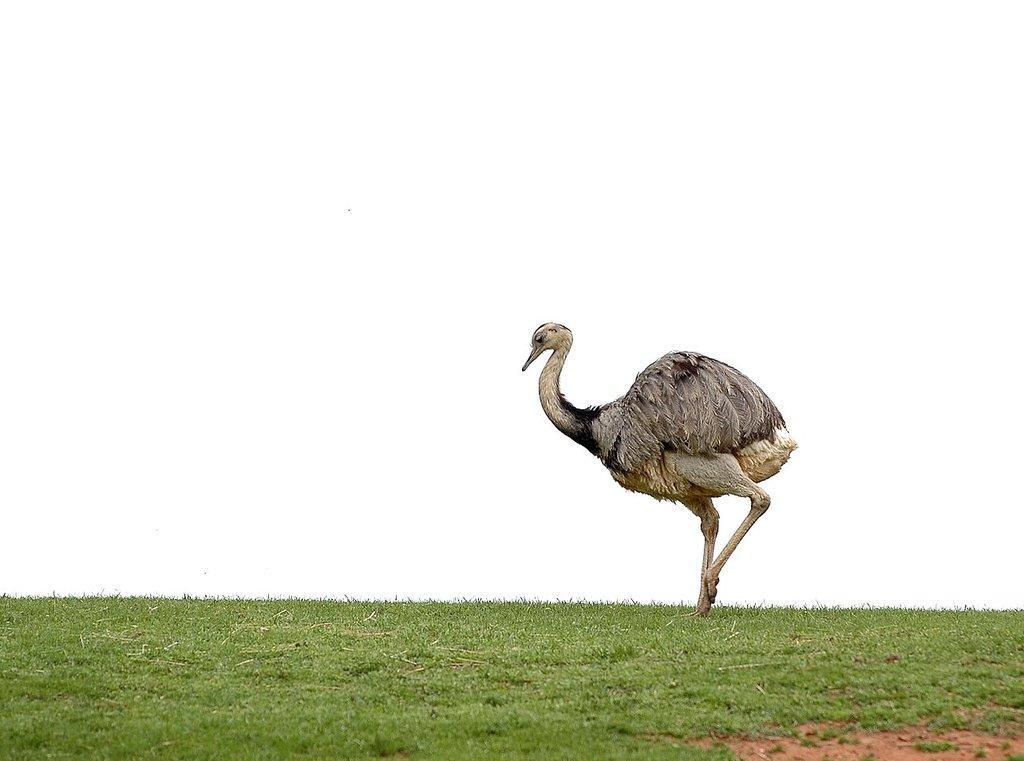Can you describe this image briefly? In this image, we can see some grass. There is a bird in the middle of the image. 